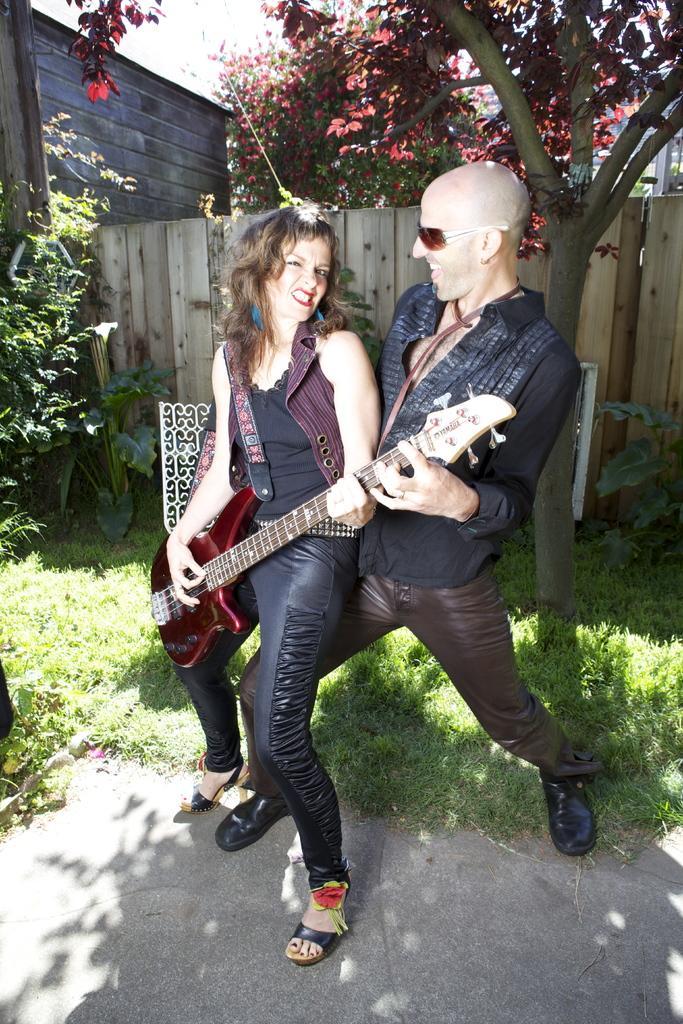Please provide a concise description of this image. There are two persons playing one guitar and in background there are trees and green grass. 